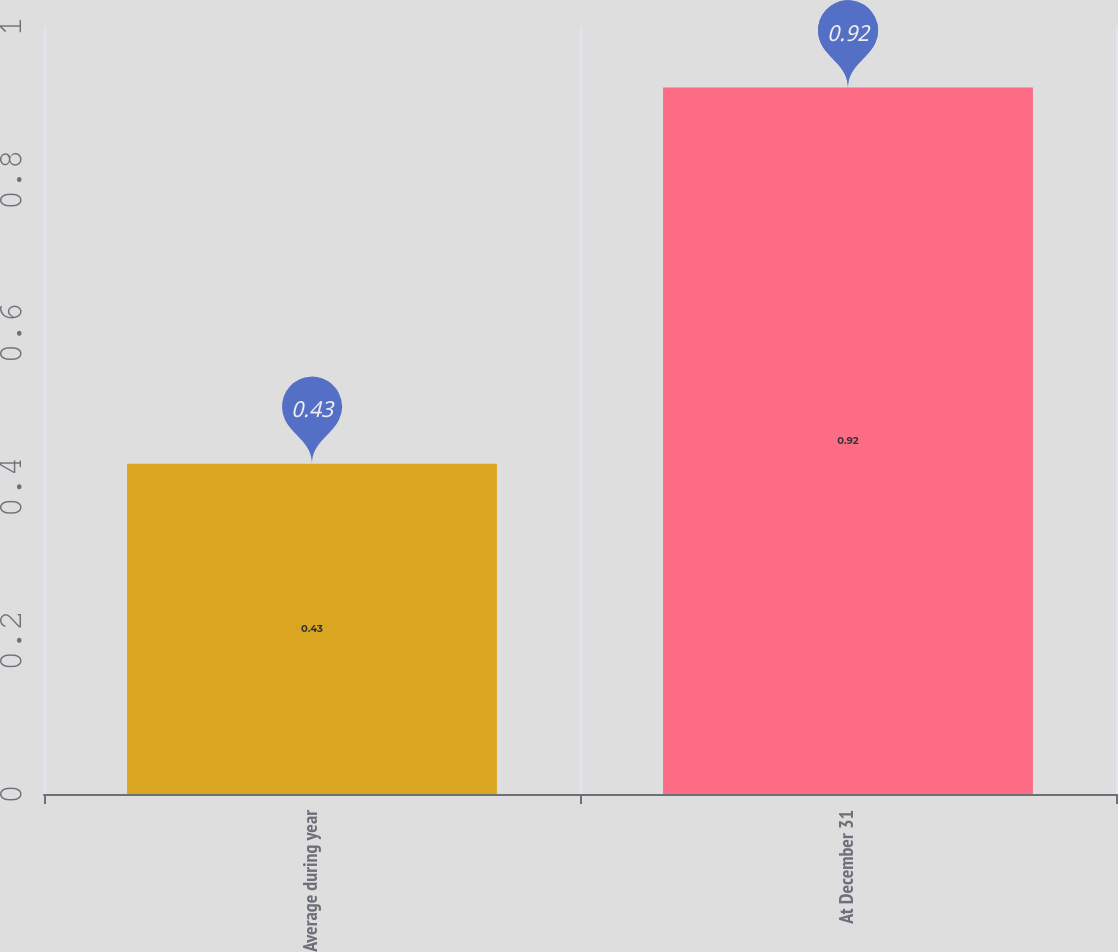Convert chart. <chart><loc_0><loc_0><loc_500><loc_500><bar_chart><fcel>Average during year<fcel>At December 31<nl><fcel>0.43<fcel>0.92<nl></chart> 